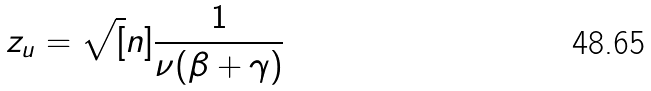<formula> <loc_0><loc_0><loc_500><loc_500>z _ { u } = \sqrt { [ } n ] { \frac { 1 } { \nu ( \beta + \gamma ) } }</formula> 